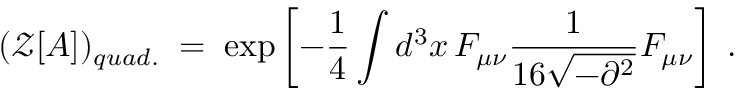Convert formula to latex. <formula><loc_0><loc_0><loc_500><loc_500>( { \mathcal { Z } } [ A ] ) _ { q u a d . } \, = \, \exp \left [ - \frac { 1 } { 4 } \int d ^ { 3 } x \, F _ { \mu \nu } \frac { 1 } { 1 6 \sqrt { - \partial ^ { 2 } } } F _ { \mu \nu } \right ] \, .</formula> 